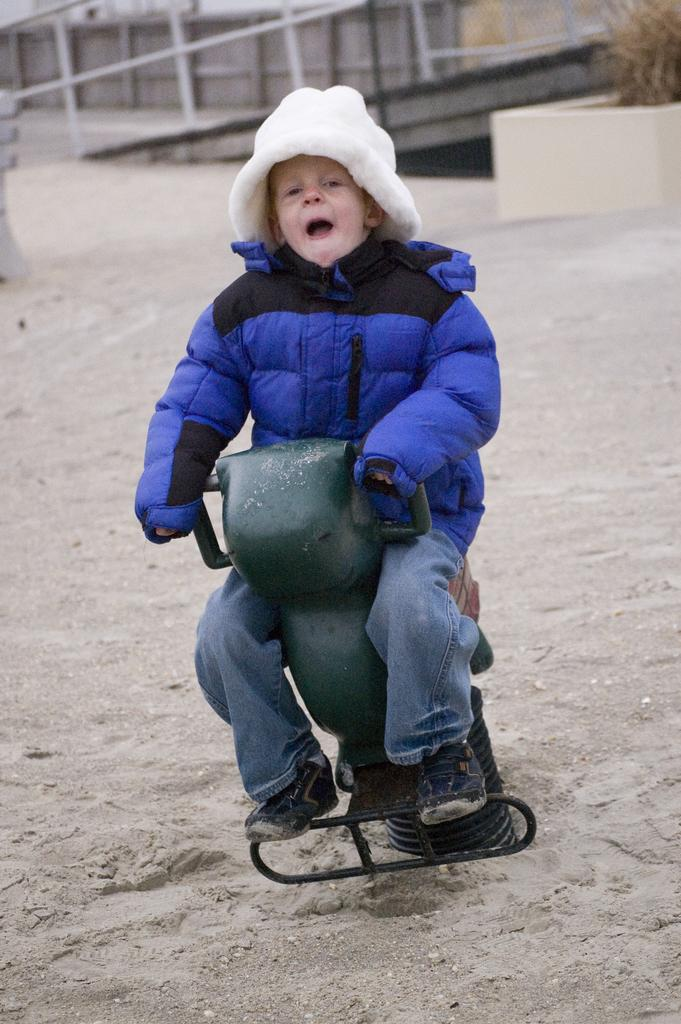Who is the main subject in the image? There is a small boy in the image. What is the boy wearing? The boy is wearing a blue color puff jacket. What is the boy sitting on? The boy is sitting on an iron spring chair. What can be seen in the background of the image? There is a white color pipe railing visible in the background. What trick is the boy performing with the pipe railing in the image? There is no trick being performed in the image; the boy is simply sitting on a chair with a pipe railing visible in the background. What is the condition of the boy in the image? The image does not provide information about the boy's condition, only his appearance and the objects around him. 